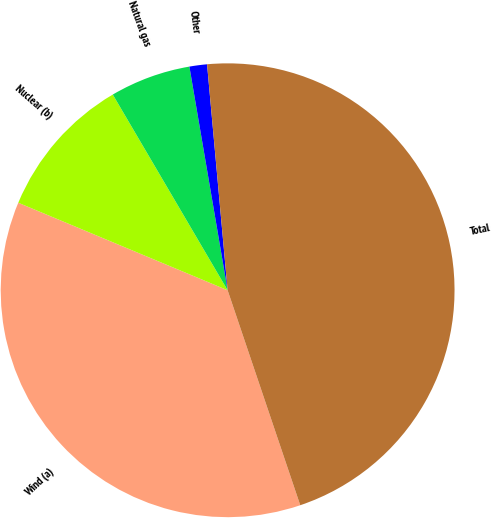Convert chart. <chart><loc_0><loc_0><loc_500><loc_500><pie_chart><fcel>Wind (a)<fcel>Nuclear (b)<fcel>Natural gas<fcel>Other<fcel>Total<nl><fcel>36.48%<fcel>10.25%<fcel>5.75%<fcel>1.25%<fcel>46.25%<nl></chart> 